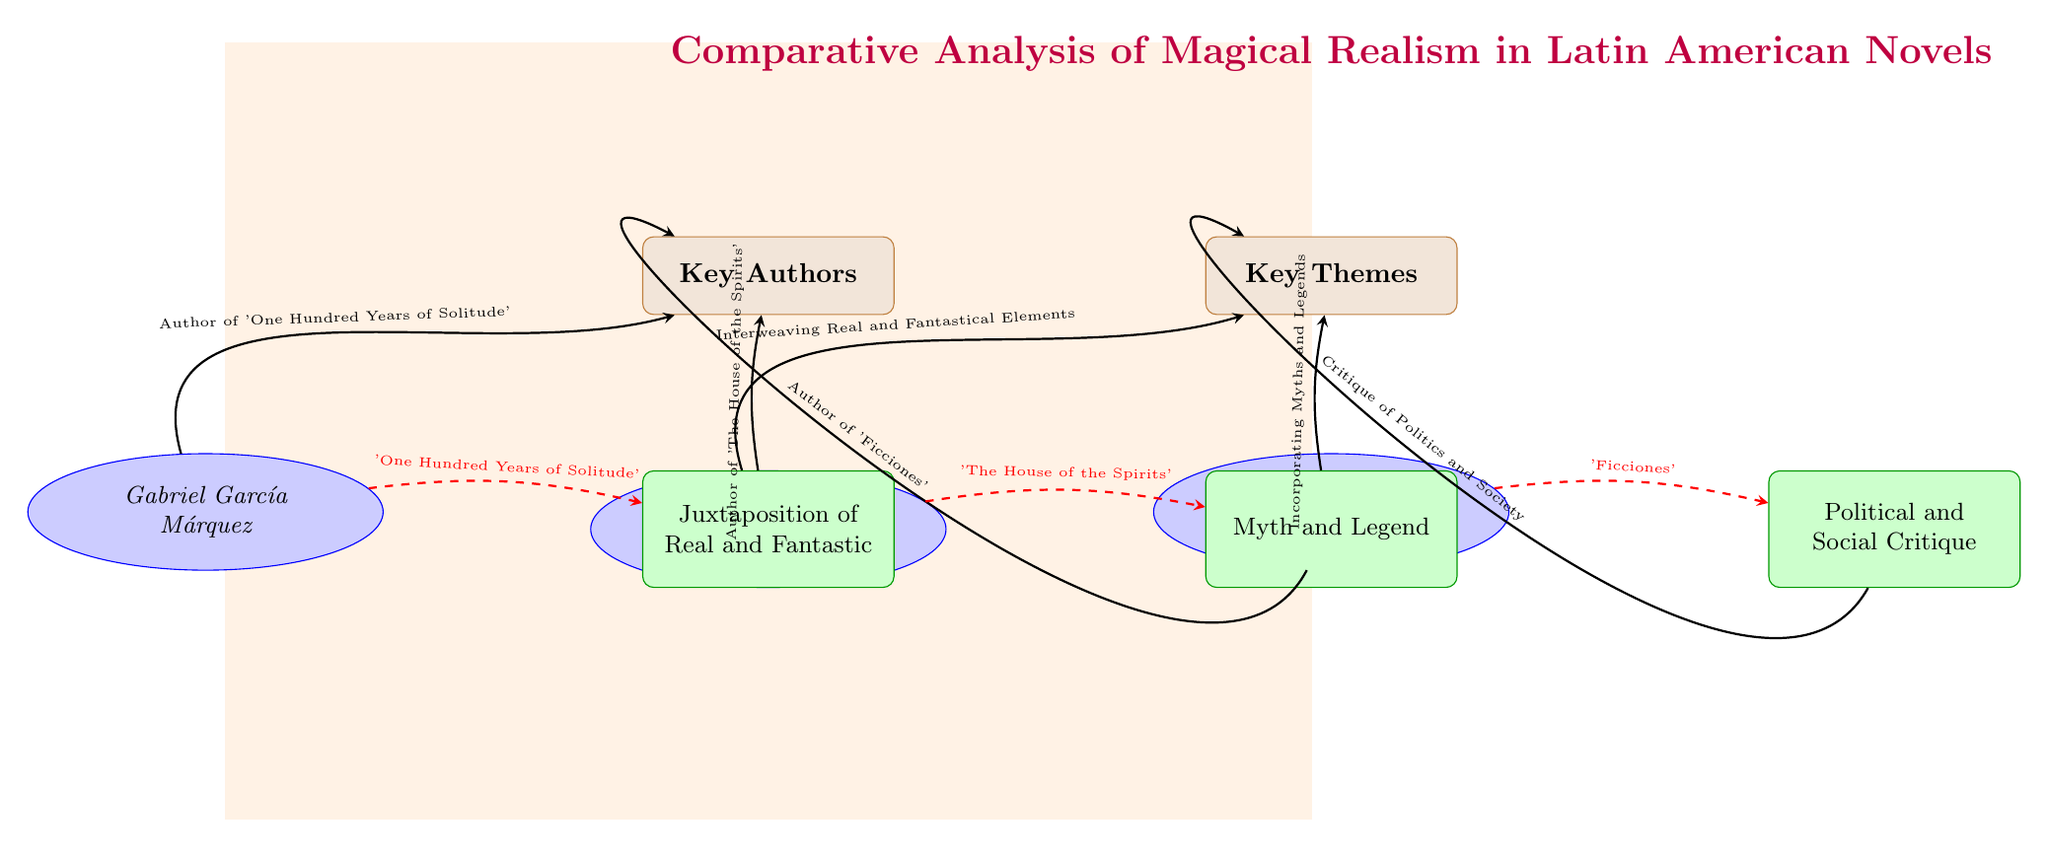What are the three key authors represented in the diagram? In the diagram, there are three ellipse nodes that represent key authors: Gabriel García Márquez, Isabel Allende, and Jorge Luis Borges.
Answer: Gabriel García Márquez, Isabel Allende, Jorge Luis Borges What theme corresponds to Gabriel García Márquez? The dashed red arrow from Gabriel García Márquez points to the node labeled “Juxtaposition of Real and Fantastic,” indicating this theme corresponds to his work.
Answer: Juxtaposition of Real and Fantastic How many key themes are shown in the diagram? The diagram has three rectangular nodes that represent key themes: Juxtaposition of Real and Fantastic, Myth and Legend, and Political and Social Critique. Thus, there are three key themes.
Answer: 3 What is the title of the diagram? The title is located at the top of the diagram and clearly indicates the overall comparison being made, which is "Comparative Analysis of Magical Realism in Latin American Novels."
Answer: Comparative Analysis of Magical Realism in Latin American Novels Which author is associated with the theme of Political and Social Critique? The dashed red arrow from Jorge Luis Borges to the theme node shows that he is associated with "Political and Social Critique."
Answer: Jorge Luis Borges What is the relationship between Isabel Allende and the theme of Myth and Legend? The diagram shows a dashed red arrow connecting Isabel Allende to the theme node labeled “Myth and Legend,” indicating that she incorporates this theme in her work.
Answer: Incorporating Myths and Legends How is the theme of Juxtaposition of Real and Fantastic represented in the works? The diagram indicates that the theme of Juxtaposition of Real and Fantastic is illustrated through Gabriel García Márquez's work, with a dashed arrow connecting them.
Answer: Interweaving Real and Fantastical Elements Which color represents the key authors in the diagram? The author nodes are styled with a blue background and outline, indicating that blue is the color representing the key authors in the diagram.
Answer: Blue 